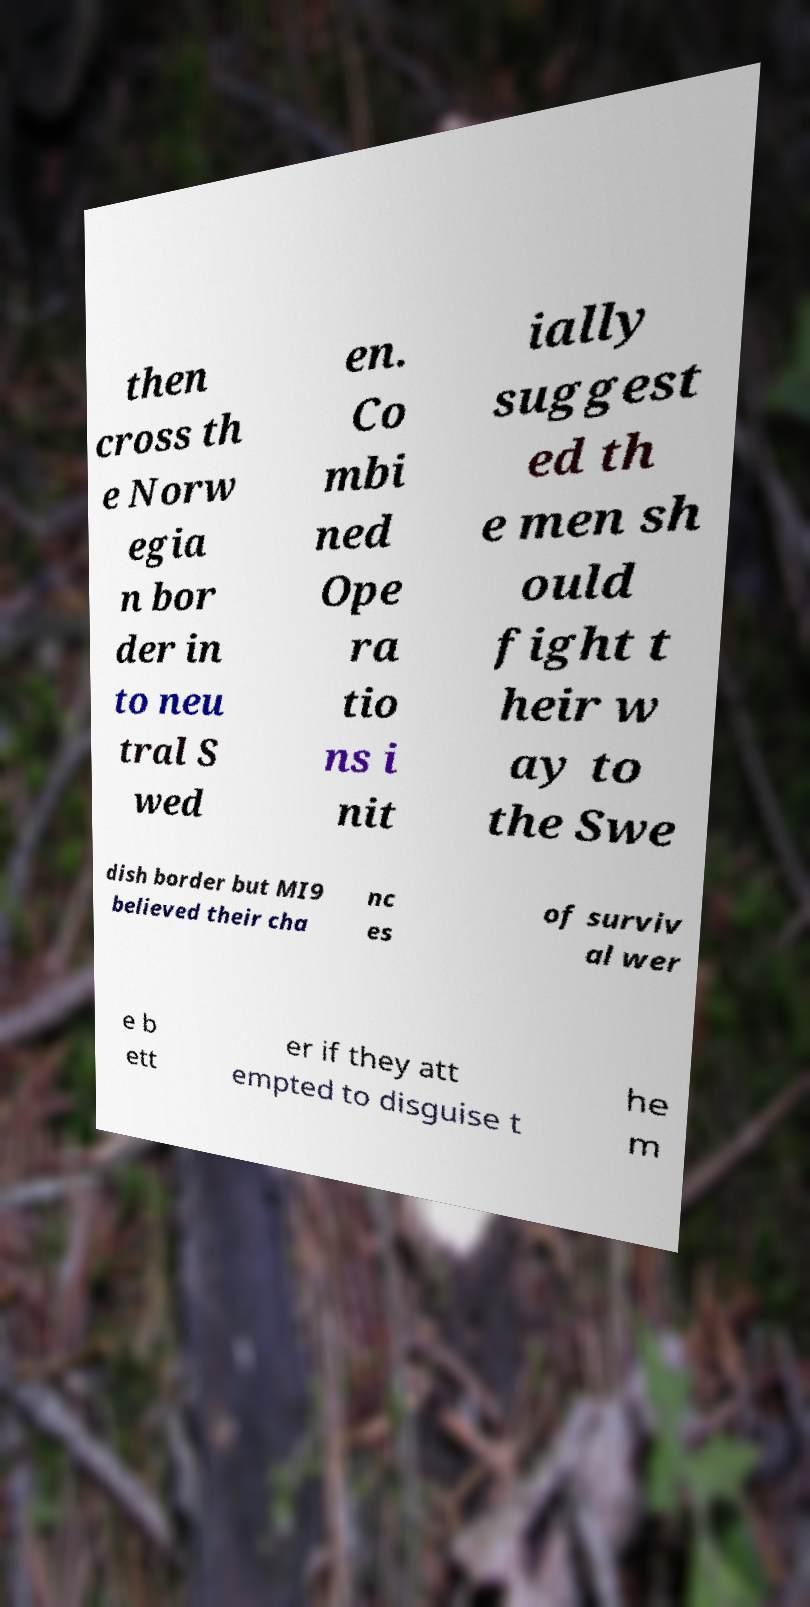Can you accurately transcribe the text from the provided image for me? then cross th e Norw egia n bor der in to neu tral S wed en. Co mbi ned Ope ra tio ns i nit ially suggest ed th e men sh ould fight t heir w ay to the Swe dish border but MI9 believed their cha nc es of surviv al wer e b ett er if they att empted to disguise t he m 